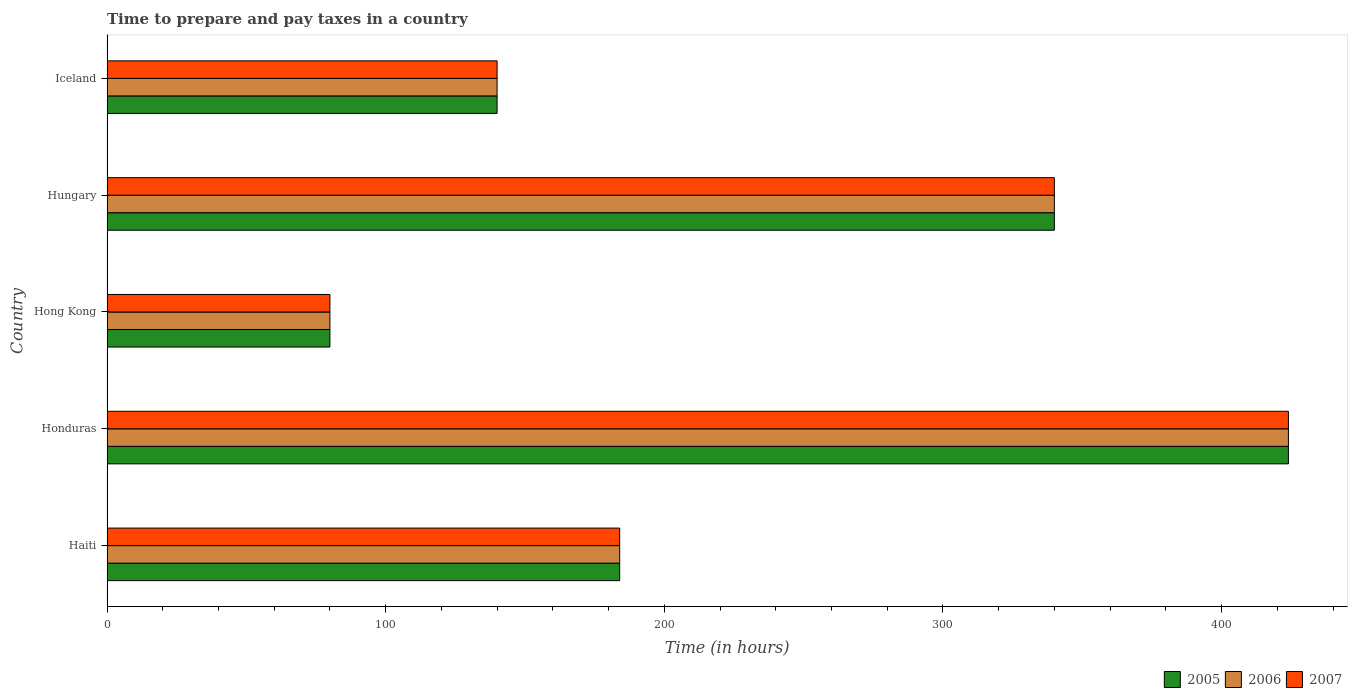How many groups of bars are there?
Provide a short and direct response. 5. Are the number of bars per tick equal to the number of legend labels?
Offer a very short reply. Yes. Are the number of bars on each tick of the Y-axis equal?
Make the answer very short. Yes. How many bars are there on the 2nd tick from the top?
Your answer should be very brief. 3. How many bars are there on the 1st tick from the bottom?
Give a very brief answer. 3. What is the label of the 4th group of bars from the top?
Ensure brevity in your answer.  Honduras. In how many cases, is the number of bars for a given country not equal to the number of legend labels?
Give a very brief answer. 0. What is the number of hours required to prepare and pay taxes in 2006 in Iceland?
Make the answer very short. 140. Across all countries, what is the maximum number of hours required to prepare and pay taxes in 2006?
Offer a terse response. 424. In which country was the number of hours required to prepare and pay taxes in 2005 maximum?
Your response must be concise. Honduras. In which country was the number of hours required to prepare and pay taxes in 2005 minimum?
Keep it short and to the point. Hong Kong. What is the total number of hours required to prepare and pay taxes in 2005 in the graph?
Provide a succinct answer. 1168. What is the difference between the number of hours required to prepare and pay taxes in 2005 in Haiti and that in Hungary?
Your response must be concise. -156. What is the average number of hours required to prepare and pay taxes in 2005 per country?
Offer a terse response. 233.6. In how many countries, is the number of hours required to prepare and pay taxes in 2006 greater than 160 hours?
Your answer should be very brief. 3. What is the ratio of the number of hours required to prepare and pay taxes in 2007 in Honduras to that in Iceland?
Offer a very short reply. 3.03. Is the number of hours required to prepare and pay taxes in 2006 in Honduras less than that in Iceland?
Offer a terse response. No. What is the difference between the highest and the lowest number of hours required to prepare and pay taxes in 2005?
Offer a terse response. 344. In how many countries, is the number of hours required to prepare and pay taxes in 2006 greater than the average number of hours required to prepare and pay taxes in 2006 taken over all countries?
Offer a very short reply. 2. Is the sum of the number of hours required to prepare and pay taxes in 2006 in Hungary and Iceland greater than the maximum number of hours required to prepare and pay taxes in 2007 across all countries?
Your response must be concise. Yes. What does the 3rd bar from the top in Hong Kong represents?
Offer a terse response. 2005. Is it the case that in every country, the sum of the number of hours required to prepare and pay taxes in 2006 and number of hours required to prepare and pay taxes in 2007 is greater than the number of hours required to prepare and pay taxes in 2005?
Make the answer very short. Yes. How many countries are there in the graph?
Make the answer very short. 5. Are the values on the major ticks of X-axis written in scientific E-notation?
Keep it short and to the point. No. Does the graph contain any zero values?
Make the answer very short. No. Does the graph contain grids?
Provide a succinct answer. No. What is the title of the graph?
Give a very brief answer. Time to prepare and pay taxes in a country. What is the label or title of the X-axis?
Provide a succinct answer. Time (in hours). What is the label or title of the Y-axis?
Give a very brief answer. Country. What is the Time (in hours) in 2005 in Haiti?
Your answer should be very brief. 184. What is the Time (in hours) of 2006 in Haiti?
Your answer should be very brief. 184. What is the Time (in hours) of 2007 in Haiti?
Make the answer very short. 184. What is the Time (in hours) of 2005 in Honduras?
Provide a short and direct response. 424. What is the Time (in hours) of 2006 in Honduras?
Provide a succinct answer. 424. What is the Time (in hours) in 2007 in Honduras?
Your answer should be very brief. 424. What is the Time (in hours) in 2005 in Hong Kong?
Make the answer very short. 80. What is the Time (in hours) in 2005 in Hungary?
Your response must be concise. 340. What is the Time (in hours) in 2006 in Hungary?
Provide a succinct answer. 340. What is the Time (in hours) in 2007 in Hungary?
Give a very brief answer. 340. What is the Time (in hours) in 2005 in Iceland?
Your answer should be very brief. 140. What is the Time (in hours) in 2006 in Iceland?
Make the answer very short. 140. What is the Time (in hours) of 2007 in Iceland?
Make the answer very short. 140. Across all countries, what is the maximum Time (in hours) in 2005?
Your response must be concise. 424. Across all countries, what is the maximum Time (in hours) of 2006?
Offer a very short reply. 424. Across all countries, what is the maximum Time (in hours) in 2007?
Your answer should be very brief. 424. Across all countries, what is the minimum Time (in hours) of 2005?
Your response must be concise. 80. Across all countries, what is the minimum Time (in hours) of 2007?
Provide a succinct answer. 80. What is the total Time (in hours) of 2005 in the graph?
Provide a short and direct response. 1168. What is the total Time (in hours) of 2006 in the graph?
Ensure brevity in your answer.  1168. What is the total Time (in hours) of 2007 in the graph?
Give a very brief answer. 1168. What is the difference between the Time (in hours) in 2005 in Haiti and that in Honduras?
Offer a terse response. -240. What is the difference between the Time (in hours) of 2006 in Haiti and that in Honduras?
Your answer should be very brief. -240. What is the difference between the Time (in hours) of 2007 in Haiti and that in Honduras?
Provide a short and direct response. -240. What is the difference between the Time (in hours) in 2005 in Haiti and that in Hong Kong?
Your response must be concise. 104. What is the difference between the Time (in hours) in 2006 in Haiti and that in Hong Kong?
Keep it short and to the point. 104. What is the difference between the Time (in hours) of 2007 in Haiti and that in Hong Kong?
Your answer should be very brief. 104. What is the difference between the Time (in hours) of 2005 in Haiti and that in Hungary?
Your response must be concise. -156. What is the difference between the Time (in hours) of 2006 in Haiti and that in Hungary?
Provide a succinct answer. -156. What is the difference between the Time (in hours) of 2007 in Haiti and that in Hungary?
Make the answer very short. -156. What is the difference between the Time (in hours) in 2005 in Haiti and that in Iceland?
Make the answer very short. 44. What is the difference between the Time (in hours) in 2006 in Haiti and that in Iceland?
Make the answer very short. 44. What is the difference between the Time (in hours) of 2005 in Honduras and that in Hong Kong?
Give a very brief answer. 344. What is the difference between the Time (in hours) of 2006 in Honduras and that in Hong Kong?
Your response must be concise. 344. What is the difference between the Time (in hours) of 2007 in Honduras and that in Hong Kong?
Offer a very short reply. 344. What is the difference between the Time (in hours) of 2007 in Honduras and that in Hungary?
Provide a short and direct response. 84. What is the difference between the Time (in hours) of 2005 in Honduras and that in Iceland?
Your answer should be compact. 284. What is the difference between the Time (in hours) of 2006 in Honduras and that in Iceland?
Offer a very short reply. 284. What is the difference between the Time (in hours) in 2007 in Honduras and that in Iceland?
Keep it short and to the point. 284. What is the difference between the Time (in hours) of 2005 in Hong Kong and that in Hungary?
Provide a short and direct response. -260. What is the difference between the Time (in hours) in 2006 in Hong Kong and that in Hungary?
Your response must be concise. -260. What is the difference between the Time (in hours) in 2007 in Hong Kong and that in Hungary?
Ensure brevity in your answer.  -260. What is the difference between the Time (in hours) in 2005 in Hong Kong and that in Iceland?
Ensure brevity in your answer.  -60. What is the difference between the Time (in hours) in 2006 in Hong Kong and that in Iceland?
Your answer should be compact. -60. What is the difference between the Time (in hours) of 2007 in Hong Kong and that in Iceland?
Your response must be concise. -60. What is the difference between the Time (in hours) in 2005 in Hungary and that in Iceland?
Provide a short and direct response. 200. What is the difference between the Time (in hours) in 2005 in Haiti and the Time (in hours) in 2006 in Honduras?
Ensure brevity in your answer.  -240. What is the difference between the Time (in hours) of 2005 in Haiti and the Time (in hours) of 2007 in Honduras?
Provide a succinct answer. -240. What is the difference between the Time (in hours) in 2006 in Haiti and the Time (in hours) in 2007 in Honduras?
Ensure brevity in your answer.  -240. What is the difference between the Time (in hours) of 2005 in Haiti and the Time (in hours) of 2006 in Hong Kong?
Give a very brief answer. 104. What is the difference between the Time (in hours) in 2005 in Haiti and the Time (in hours) in 2007 in Hong Kong?
Provide a succinct answer. 104. What is the difference between the Time (in hours) of 2006 in Haiti and the Time (in hours) of 2007 in Hong Kong?
Your response must be concise. 104. What is the difference between the Time (in hours) in 2005 in Haiti and the Time (in hours) in 2006 in Hungary?
Offer a terse response. -156. What is the difference between the Time (in hours) in 2005 in Haiti and the Time (in hours) in 2007 in Hungary?
Provide a short and direct response. -156. What is the difference between the Time (in hours) in 2006 in Haiti and the Time (in hours) in 2007 in Hungary?
Your response must be concise. -156. What is the difference between the Time (in hours) in 2005 in Haiti and the Time (in hours) in 2007 in Iceland?
Offer a terse response. 44. What is the difference between the Time (in hours) of 2006 in Haiti and the Time (in hours) of 2007 in Iceland?
Ensure brevity in your answer.  44. What is the difference between the Time (in hours) of 2005 in Honduras and the Time (in hours) of 2006 in Hong Kong?
Make the answer very short. 344. What is the difference between the Time (in hours) of 2005 in Honduras and the Time (in hours) of 2007 in Hong Kong?
Keep it short and to the point. 344. What is the difference between the Time (in hours) of 2006 in Honduras and the Time (in hours) of 2007 in Hong Kong?
Your answer should be compact. 344. What is the difference between the Time (in hours) of 2005 in Honduras and the Time (in hours) of 2006 in Hungary?
Keep it short and to the point. 84. What is the difference between the Time (in hours) of 2005 in Honduras and the Time (in hours) of 2007 in Hungary?
Your answer should be compact. 84. What is the difference between the Time (in hours) in 2006 in Honduras and the Time (in hours) in 2007 in Hungary?
Ensure brevity in your answer.  84. What is the difference between the Time (in hours) of 2005 in Honduras and the Time (in hours) of 2006 in Iceland?
Ensure brevity in your answer.  284. What is the difference between the Time (in hours) in 2005 in Honduras and the Time (in hours) in 2007 in Iceland?
Provide a succinct answer. 284. What is the difference between the Time (in hours) in 2006 in Honduras and the Time (in hours) in 2007 in Iceland?
Offer a terse response. 284. What is the difference between the Time (in hours) in 2005 in Hong Kong and the Time (in hours) in 2006 in Hungary?
Your answer should be compact. -260. What is the difference between the Time (in hours) in 2005 in Hong Kong and the Time (in hours) in 2007 in Hungary?
Provide a succinct answer. -260. What is the difference between the Time (in hours) of 2006 in Hong Kong and the Time (in hours) of 2007 in Hungary?
Your response must be concise. -260. What is the difference between the Time (in hours) in 2005 in Hong Kong and the Time (in hours) in 2006 in Iceland?
Your response must be concise. -60. What is the difference between the Time (in hours) in 2005 in Hong Kong and the Time (in hours) in 2007 in Iceland?
Provide a succinct answer. -60. What is the difference between the Time (in hours) in 2006 in Hong Kong and the Time (in hours) in 2007 in Iceland?
Offer a very short reply. -60. What is the difference between the Time (in hours) of 2005 in Hungary and the Time (in hours) of 2006 in Iceland?
Make the answer very short. 200. What is the difference between the Time (in hours) in 2005 in Hungary and the Time (in hours) in 2007 in Iceland?
Your answer should be compact. 200. What is the difference between the Time (in hours) in 2006 in Hungary and the Time (in hours) in 2007 in Iceland?
Keep it short and to the point. 200. What is the average Time (in hours) in 2005 per country?
Your answer should be very brief. 233.6. What is the average Time (in hours) in 2006 per country?
Provide a succinct answer. 233.6. What is the average Time (in hours) of 2007 per country?
Provide a short and direct response. 233.6. What is the difference between the Time (in hours) in 2005 and Time (in hours) in 2007 in Haiti?
Offer a terse response. 0. What is the difference between the Time (in hours) of 2006 and Time (in hours) of 2007 in Haiti?
Provide a short and direct response. 0. What is the difference between the Time (in hours) of 2005 and Time (in hours) of 2007 in Honduras?
Offer a terse response. 0. What is the difference between the Time (in hours) in 2005 and Time (in hours) in 2006 in Hong Kong?
Your answer should be compact. 0. What is the difference between the Time (in hours) in 2005 and Time (in hours) in 2007 in Hong Kong?
Your response must be concise. 0. What is the difference between the Time (in hours) in 2006 and Time (in hours) in 2007 in Hong Kong?
Your answer should be very brief. 0. What is the difference between the Time (in hours) of 2005 and Time (in hours) of 2007 in Hungary?
Provide a short and direct response. 0. What is the difference between the Time (in hours) of 2005 and Time (in hours) of 2006 in Iceland?
Your answer should be compact. 0. What is the ratio of the Time (in hours) in 2005 in Haiti to that in Honduras?
Your answer should be very brief. 0.43. What is the ratio of the Time (in hours) in 2006 in Haiti to that in Honduras?
Make the answer very short. 0.43. What is the ratio of the Time (in hours) in 2007 in Haiti to that in Honduras?
Offer a terse response. 0.43. What is the ratio of the Time (in hours) of 2005 in Haiti to that in Hong Kong?
Offer a terse response. 2.3. What is the ratio of the Time (in hours) in 2006 in Haiti to that in Hong Kong?
Offer a terse response. 2.3. What is the ratio of the Time (in hours) in 2005 in Haiti to that in Hungary?
Give a very brief answer. 0.54. What is the ratio of the Time (in hours) in 2006 in Haiti to that in Hungary?
Keep it short and to the point. 0.54. What is the ratio of the Time (in hours) of 2007 in Haiti to that in Hungary?
Offer a terse response. 0.54. What is the ratio of the Time (in hours) in 2005 in Haiti to that in Iceland?
Your answer should be very brief. 1.31. What is the ratio of the Time (in hours) of 2006 in Haiti to that in Iceland?
Your answer should be very brief. 1.31. What is the ratio of the Time (in hours) in 2007 in Haiti to that in Iceland?
Your response must be concise. 1.31. What is the ratio of the Time (in hours) of 2005 in Honduras to that in Hong Kong?
Give a very brief answer. 5.3. What is the ratio of the Time (in hours) of 2007 in Honduras to that in Hong Kong?
Offer a very short reply. 5.3. What is the ratio of the Time (in hours) of 2005 in Honduras to that in Hungary?
Give a very brief answer. 1.25. What is the ratio of the Time (in hours) in 2006 in Honduras to that in Hungary?
Provide a short and direct response. 1.25. What is the ratio of the Time (in hours) in 2007 in Honduras to that in Hungary?
Offer a very short reply. 1.25. What is the ratio of the Time (in hours) of 2005 in Honduras to that in Iceland?
Your response must be concise. 3.03. What is the ratio of the Time (in hours) of 2006 in Honduras to that in Iceland?
Your answer should be compact. 3.03. What is the ratio of the Time (in hours) in 2007 in Honduras to that in Iceland?
Offer a very short reply. 3.03. What is the ratio of the Time (in hours) in 2005 in Hong Kong to that in Hungary?
Ensure brevity in your answer.  0.24. What is the ratio of the Time (in hours) of 2006 in Hong Kong to that in Hungary?
Your response must be concise. 0.24. What is the ratio of the Time (in hours) of 2007 in Hong Kong to that in Hungary?
Offer a very short reply. 0.24. What is the ratio of the Time (in hours) in 2006 in Hong Kong to that in Iceland?
Ensure brevity in your answer.  0.57. What is the ratio of the Time (in hours) in 2007 in Hong Kong to that in Iceland?
Ensure brevity in your answer.  0.57. What is the ratio of the Time (in hours) of 2005 in Hungary to that in Iceland?
Give a very brief answer. 2.43. What is the ratio of the Time (in hours) in 2006 in Hungary to that in Iceland?
Provide a succinct answer. 2.43. What is the ratio of the Time (in hours) in 2007 in Hungary to that in Iceland?
Ensure brevity in your answer.  2.43. What is the difference between the highest and the second highest Time (in hours) in 2007?
Your response must be concise. 84. What is the difference between the highest and the lowest Time (in hours) of 2005?
Your answer should be compact. 344. What is the difference between the highest and the lowest Time (in hours) in 2006?
Offer a very short reply. 344. What is the difference between the highest and the lowest Time (in hours) of 2007?
Your response must be concise. 344. 